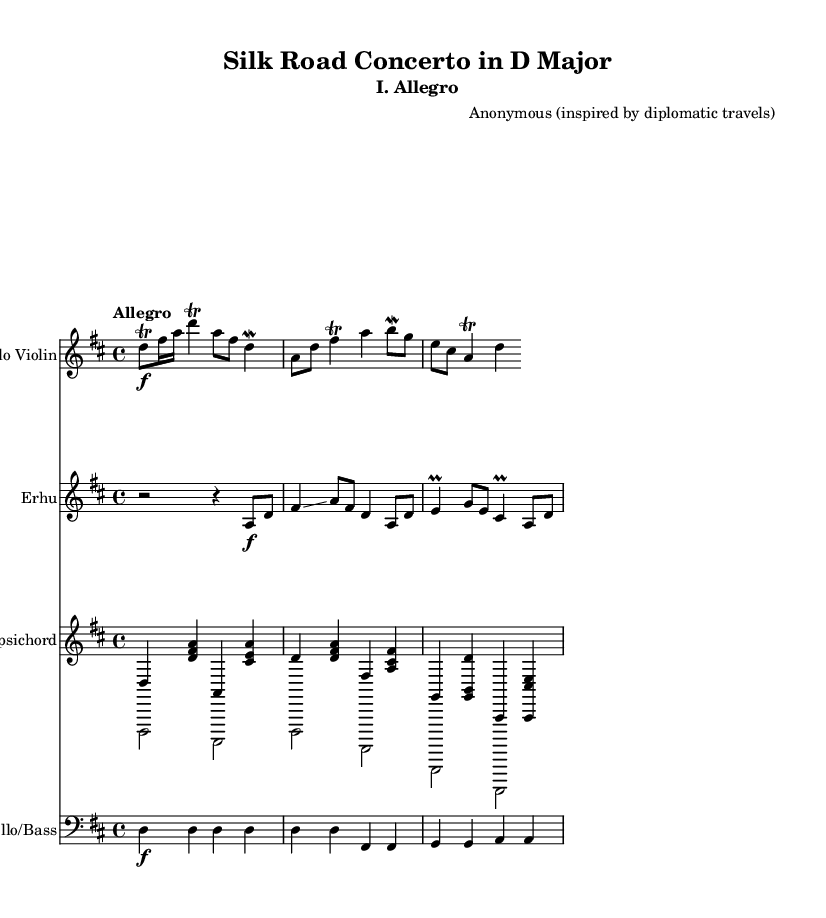What is the key signature of this music? The key signature is D major, which has two sharps (F# and C#). This can be identified from the key signature displayed at the beginning of the sheet music.
Answer: D major What is the time signature of this music? The time signature is 4/4, indicated at the beginning of the piece. This means there are four beats in each measure and a quarter note receives one beat.
Answer: 4/4 What is the tempo marking of this music? The tempo marking indicated at the beginning is "Allegro," which typically means a fast and lively pace. This can be found next to the time signature at the top of the score.
Answer: Allegro How many measures are in the solo violin part? The solo violin part contains four measures. This can be determined by counting the number of vertical lines (barlines) that separate the measures in the staff.
Answer: Four Which instrument plays the glissando? The erhu plays the glissando, as it is specifically indicated in the notes of the erhu staff. The glissando is a technique that connects two notes smoothly in a sliding manner, noted with the term "glissando" above the relevant notes in that part.
Answer: Erhu What type of music structure is predominantly used in Baroque concertos? The Baroque concertos typically follow a three-movement structure, often outlined as fast-slow-fast. This piece demonstrates that structure as it is implied through the title and the musical parts listed.
Answer: Three-movement What is the purpose of the mordent in the violin part? The mordent in the violin part serves as an ornament, which briefly embellishes a note by alternating it with a note below. This technique is characteristic of Baroque music, adding expressiveness to the melody. The mordent's notation can be seen in the solo violin part.
Answer: Ornament 